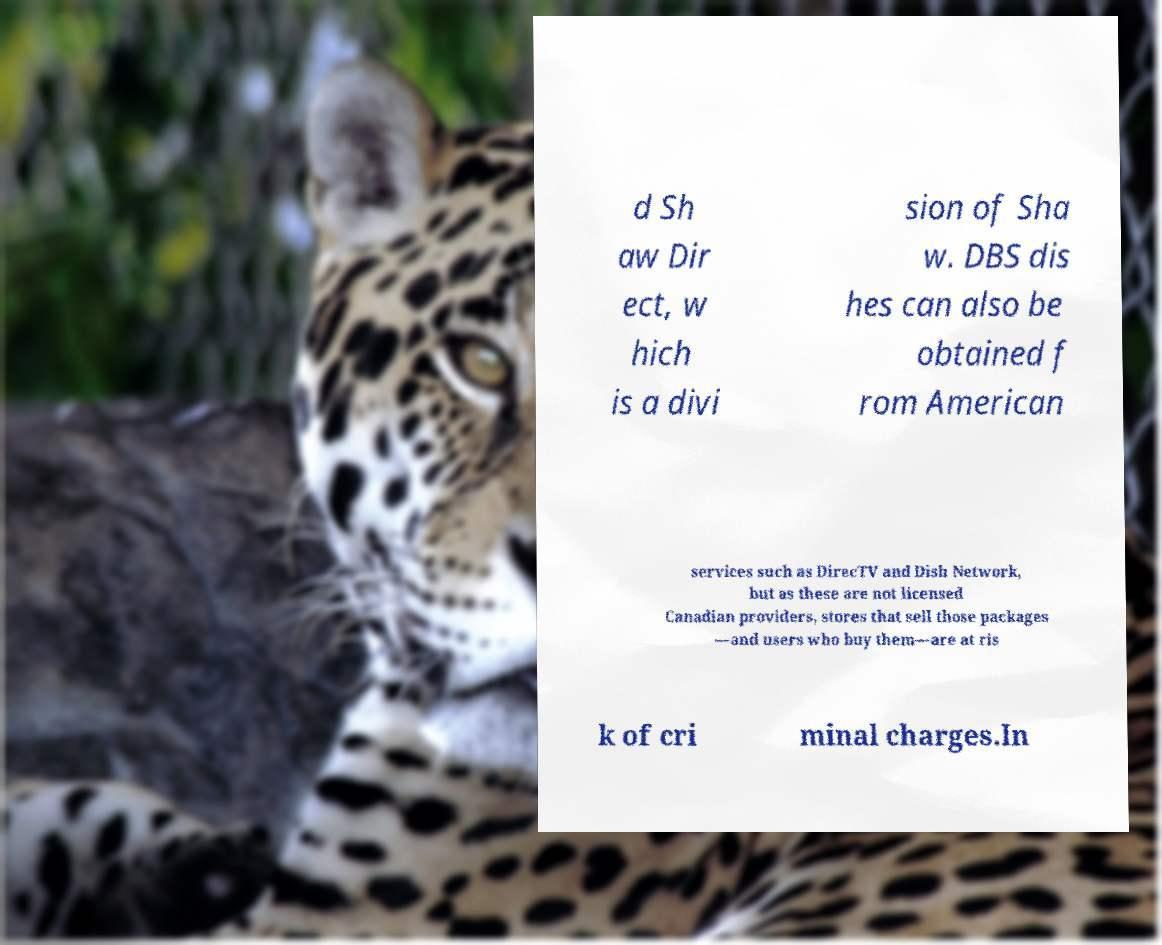I need the written content from this picture converted into text. Can you do that? d Sh aw Dir ect, w hich is a divi sion of Sha w. DBS dis hes can also be obtained f rom American services such as DirecTV and Dish Network, but as these are not licensed Canadian providers, stores that sell those packages —and users who buy them—are at ris k of cri minal charges.In 